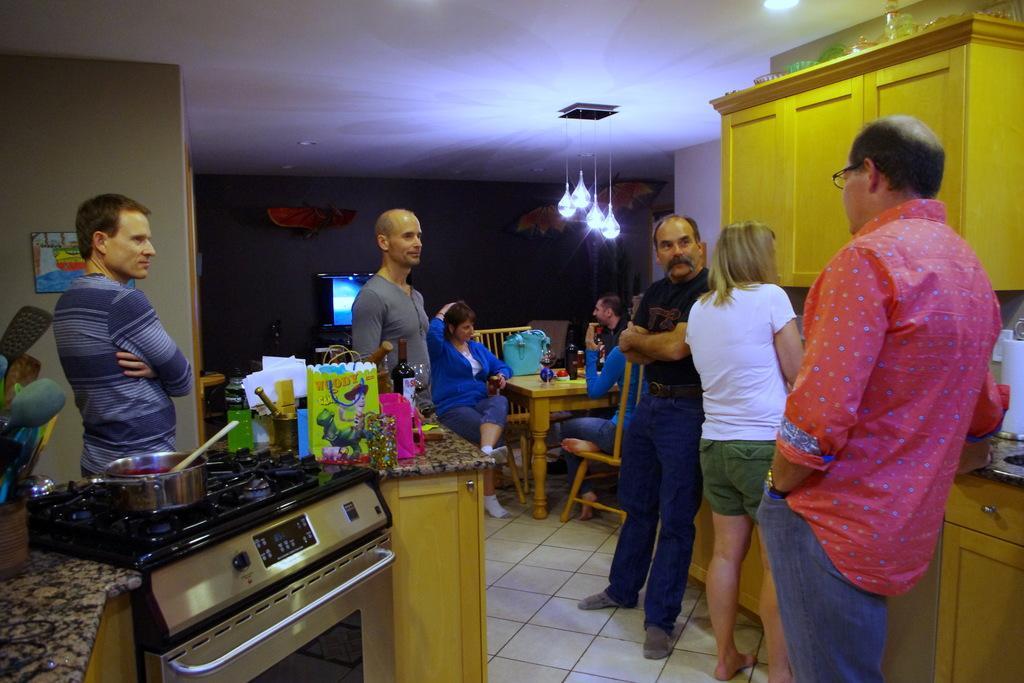In one or two sentences, can you explain what this image depicts? To the left side there is a table with cup and spoons in it. Beside the table there is a stove with kettle on it. Beside the stove there is a table with packet, glass, bottle and few other items on it. Behind the stove there's a man with blue shirt is standing. To the right side corner there is a man with pink shirt is standing. Beside him there is a lady with white t-shirt is standing. And beside her there is a man with black t-shirt is standing. In front of them to the wall there are few cupboards. In the background there are few people sitting on the chairs. In front of them there is a table with blue bag and few other items on it. Behind them to the wall there is a TV. To the top of the image on the roof there are four light bulbs hanging. 